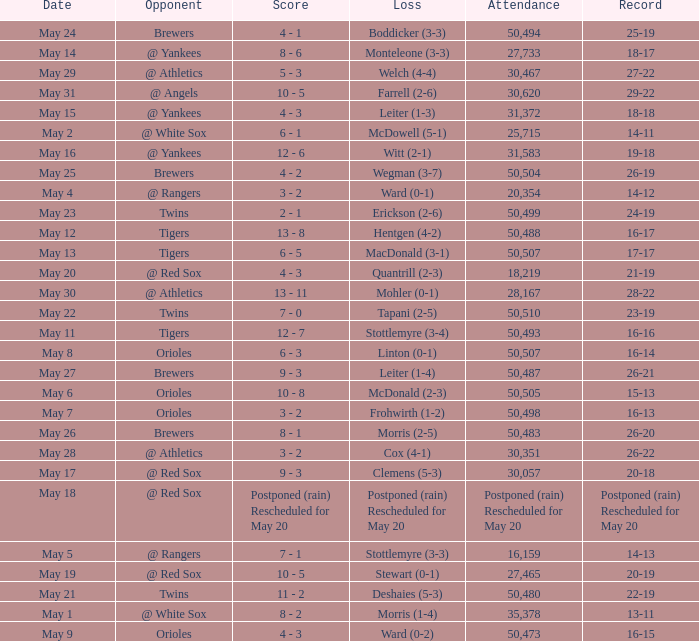On May 29 which team had the loss? Welch (4-4). 